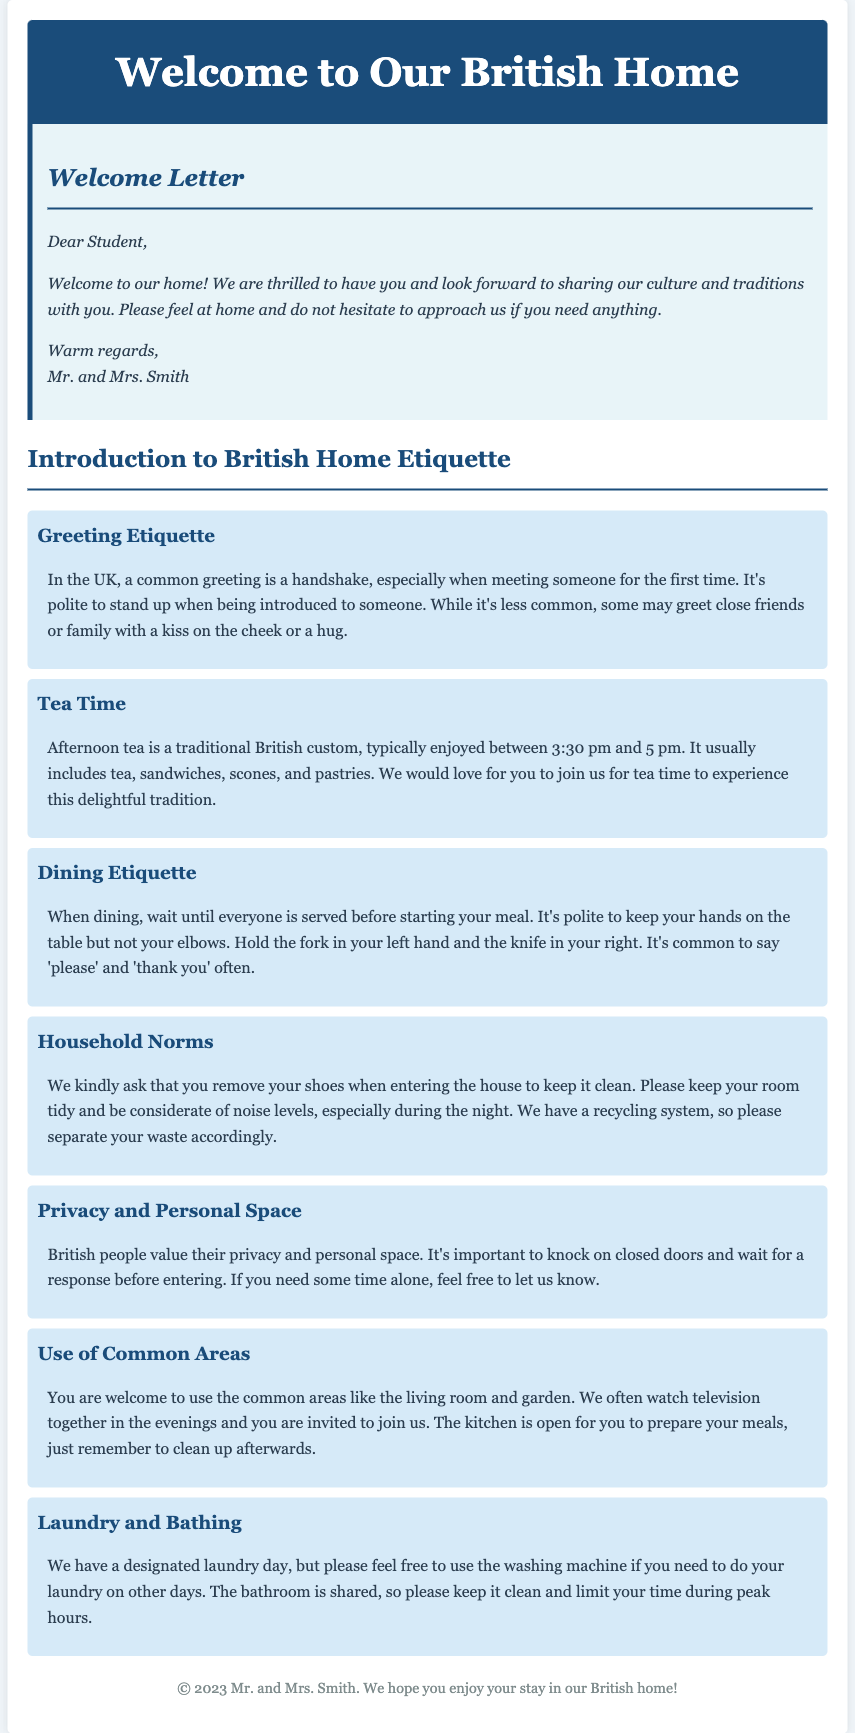What is the maximum width of the container? The document states that the container has a maximum width of 800 pixels, which is mentioned in the CSS styling.
Answer: 800px Who is the letter addressed to? The welcome letter is specifically addressed to the student, as indicated in the greeting.
Answer: Student What time is afternoon tea typically enjoyed? The document mentions that afternoon tea is usually enjoyed between 3:30 pm and 5 pm.
Answer: 3:30 pm and 5 pm What should you do before eating at the dining table? It is mentioned that one should wait until everyone is served before starting the meal.
Answer: Wait until everyone is served What is a common greeting in the UK? The document states that a handshake is a common greeting when meeting someone for the first time.
Answer: Handshake What should you do when entering the house? It is requested that you remove your shoes when entering the house to keep it clean.
Answer: Remove your shoes How is the bathroom shared according to the document? The document indicates that the bathroom is shared and emphasizes maintaining cleanliness.
Answer: Clean and limit time What is the purpose of knocking on closed doors? The document explains that knocking on closed doors respects privacy, waiting for a response before entering.
Answer: Respect privacy What is invited use of common areas? The living room and garden are mentioned as common areas you are welcome to use.
Answer: Living room and garden 